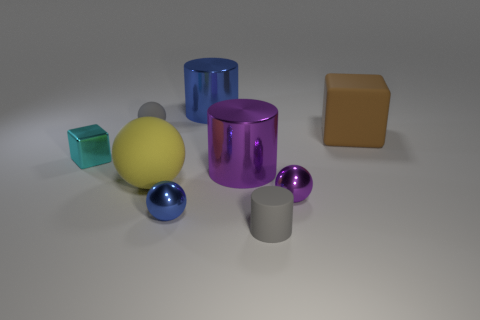Subtract 1 cylinders. How many cylinders are left? 2 Subtract all big balls. How many balls are left? 3 Subtract all yellow balls. How many balls are left? 3 Subtract all cyan spheres. Subtract all purple blocks. How many spheres are left? 4 Subtract all spheres. How many objects are left? 5 Subtract 1 cyan blocks. How many objects are left? 8 Subtract all big brown matte blocks. Subtract all big spheres. How many objects are left? 7 Add 1 cylinders. How many cylinders are left? 4 Add 3 red spheres. How many red spheres exist? 3 